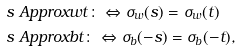Convert formula to latex. <formula><loc_0><loc_0><loc_500><loc_500>& s \ A p p r o x { w } t \colon \Leftrightarrow \sigma _ { w } ( s ) = \sigma _ { w } ( t ) \\ & s \ A p p r o x { b } t \colon \Leftrightarrow \sigma _ { b } ( - s ) = \sigma _ { b } ( - t ) ,</formula> 